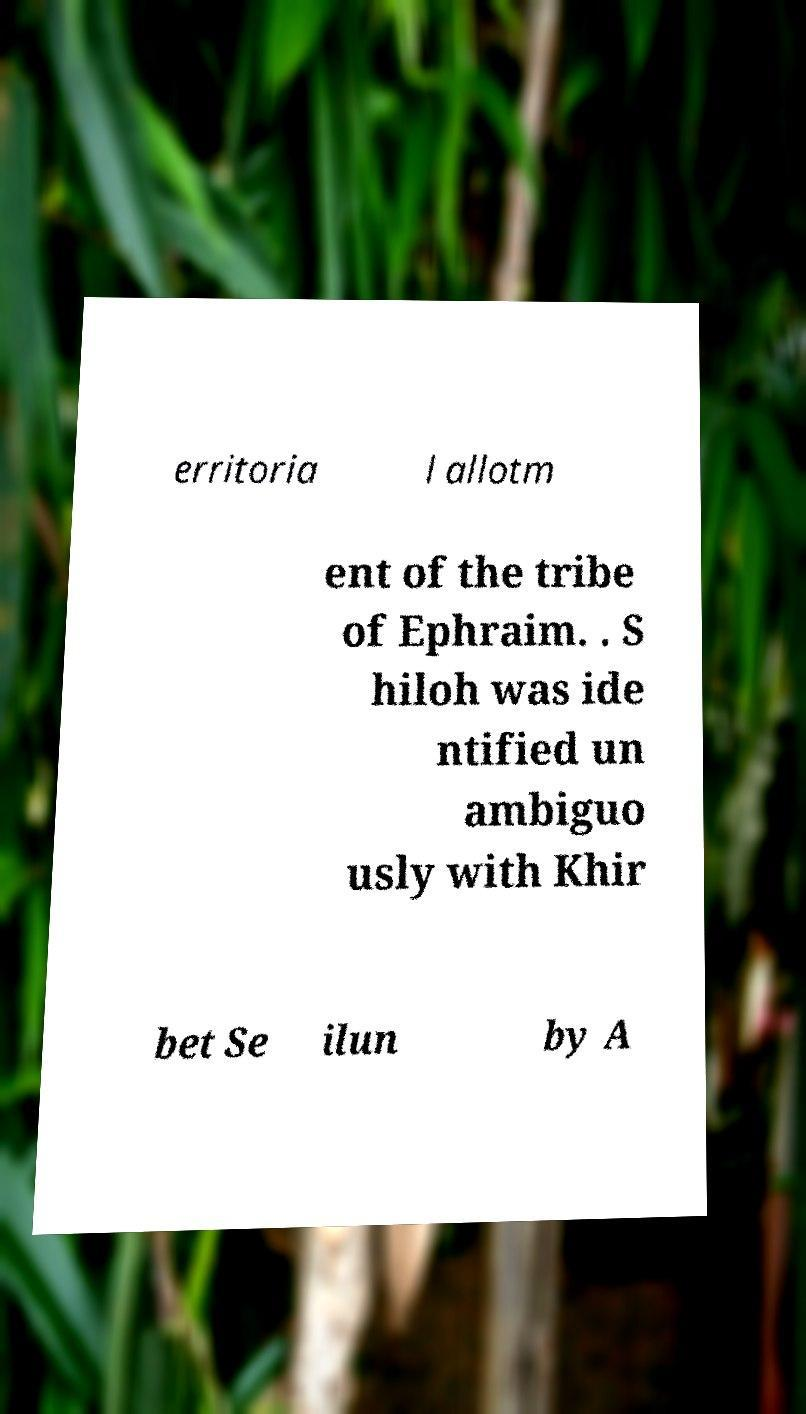There's text embedded in this image that I need extracted. Can you transcribe it verbatim? erritoria l allotm ent of the tribe of Ephraim. . S hiloh was ide ntified un ambiguo usly with Khir bet Se ilun by A 